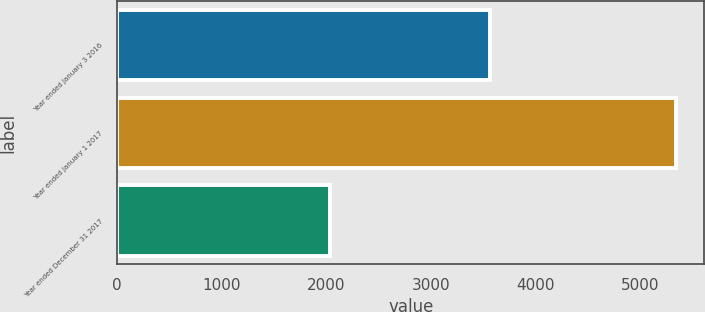Convert chart to OTSL. <chart><loc_0><loc_0><loc_500><loc_500><bar_chart><fcel>Year ended January 3 2016<fcel>Year ended January 1 2017<fcel>Year ended December 31 2017<nl><fcel>3564<fcel>5346<fcel>2038<nl></chart> 